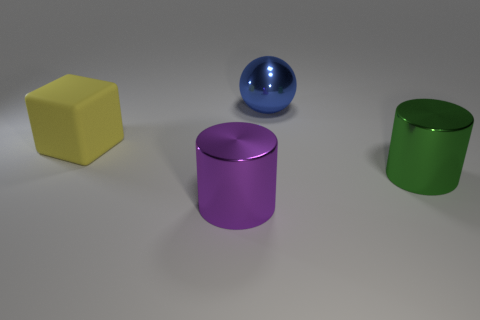Is the number of green rubber blocks less than the number of blue metal balls?
Make the answer very short. Yes. Is the material of the large purple cylinder the same as the big blue thing?
Offer a terse response. Yes. What number of other objects are the same color as the shiny sphere?
Offer a very short reply. 0. Are there more blue metal things than large metal cylinders?
Your answer should be very brief. No. There is a yellow rubber thing; is it the same size as the thing behind the big yellow matte block?
Ensure brevity in your answer.  Yes. What is the color of the cylinder behind the purple thing?
Make the answer very short. Green. How many cyan objects are tiny objects or metal balls?
Ensure brevity in your answer.  0. What is the color of the big cube?
Your answer should be very brief. Yellow. Is there anything else that has the same material as the yellow cube?
Your response must be concise. No. Are there fewer big blue shiny spheres on the left side of the green metal cylinder than shiny things that are right of the purple metal cylinder?
Your response must be concise. Yes. 